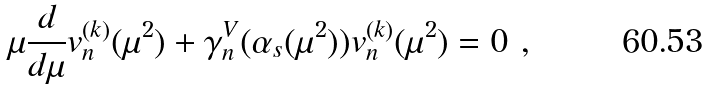Convert formula to latex. <formula><loc_0><loc_0><loc_500><loc_500>\mu \frac { d } { d \mu } v _ { n } ^ { ( k ) } ( \mu ^ { 2 } ) + \gamma _ { n } ^ { V } ( \alpha _ { s } ( \mu ^ { 2 } ) ) v _ { n } ^ { ( k ) } ( \mu ^ { 2 } ) = 0 \ ,</formula> 